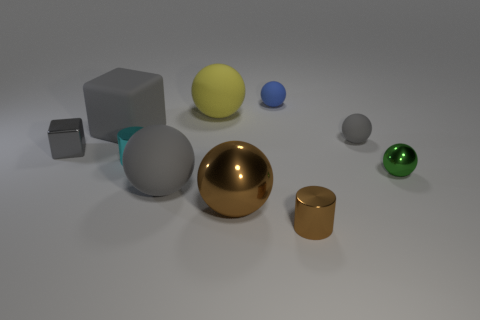Subtract 2 balls. How many balls are left? 4 Subtract all blue balls. How many balls are left? 5 Subtract all green shiny balls. How many balls are left? 5 Subtract all purple spheres. Subtract all brown cubes. How many spheres are left? 6 Subtract all cubes. How many objects are left? 8 Add 9 tiny green metallic things. How many tiny green metallic things are left? 10 Add 1 shiny objects. How many shiny objects exist? 6 Subtract 0 brown cubes. How many objects are left? 10 Subtract all big brown metal objects. Subtract all gray metal things. How many objects are left? 8 